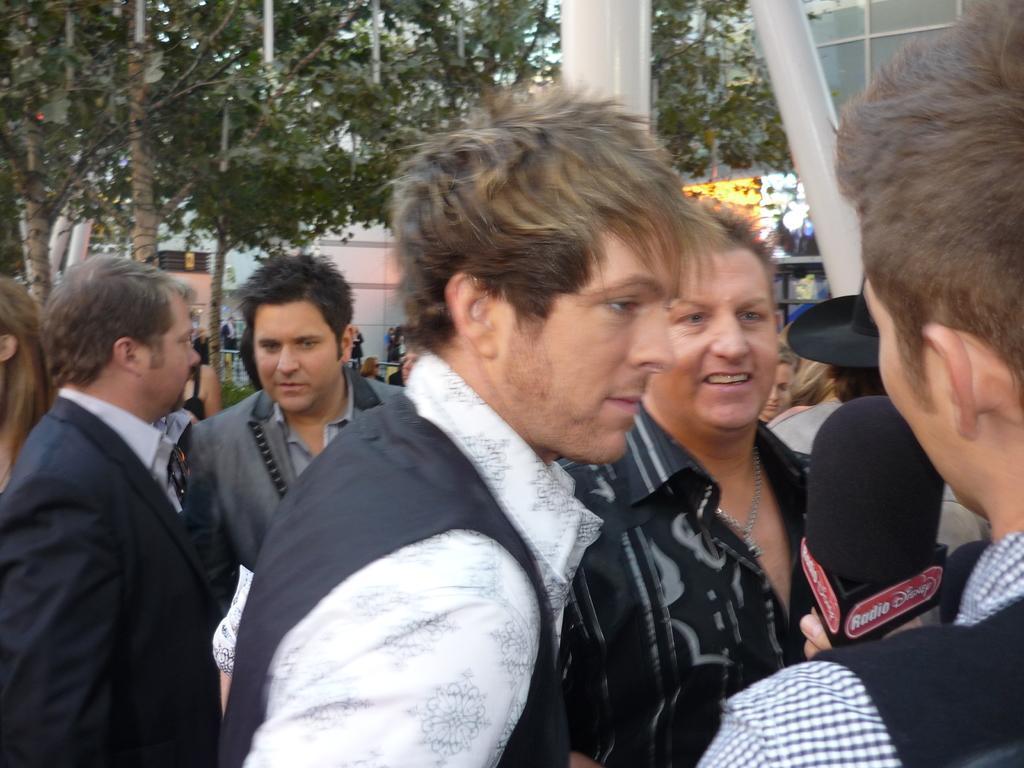Please provide a concise description of this image. In this image we can see many persons talking to each other. In the background we can see trees, buildings, persons and sky. 